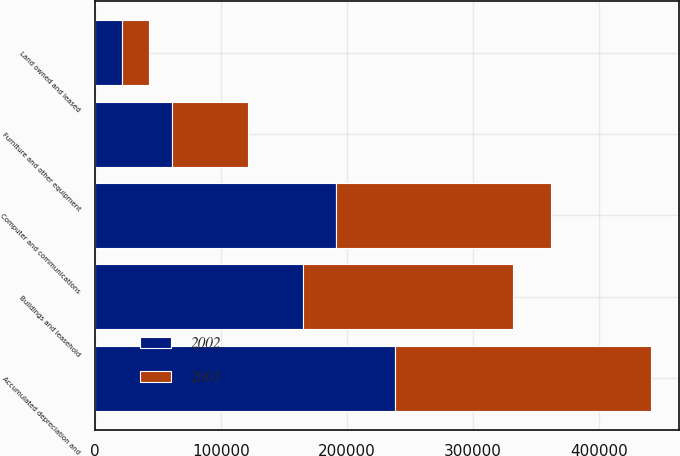Convert chart. <chart><loc_0><loc_0><loc_500><loc_500><stacked_bar_chart><ecel><fcel>Computer and communications<fcel>Buildings and leasehold<fcel>Furniture and other equipment<fcel>Land owned and leased<fcel>Accumulated depreciation and<nl><fcel>2003<fcel>170120<fcel>166568<fcel>60276<fcel>21503<fcel>202877<nl><fcel>2002<fcel>191118<fcel>165127<fcel>61479<fcel>21503<fcel>238133<nl></chart> 